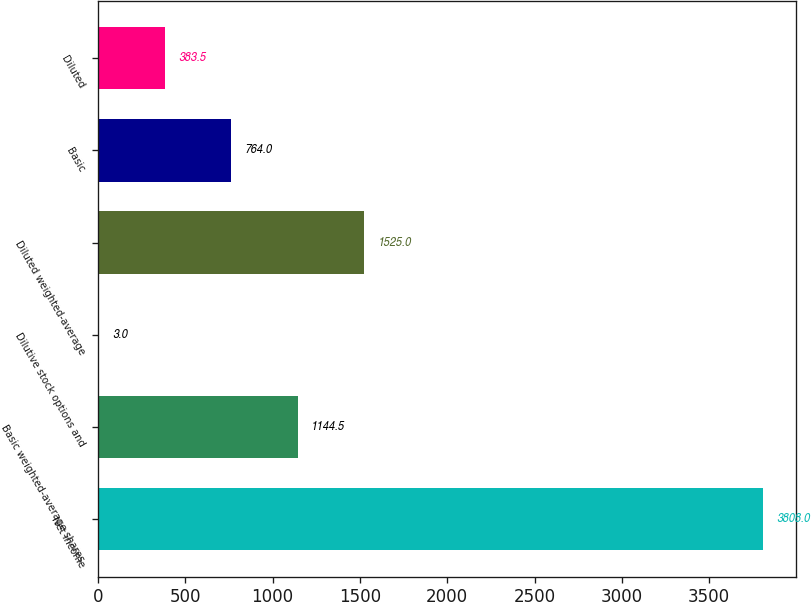Convert chart to OTSL. <chart><loc_0><loc_0><loc_500><loc_500><bar_chart><fcel>Net income<fcel>Basic weighted-average shares<fcel>Dilutive stock options and<fcel>Diluted weighted-average<fcel>Basic<fcel>Diluted<nl><fcel>3808<fcel>1144.5<fcel>3<fcel>1525<fcel>764<fcel>383.5<nl></chart> 